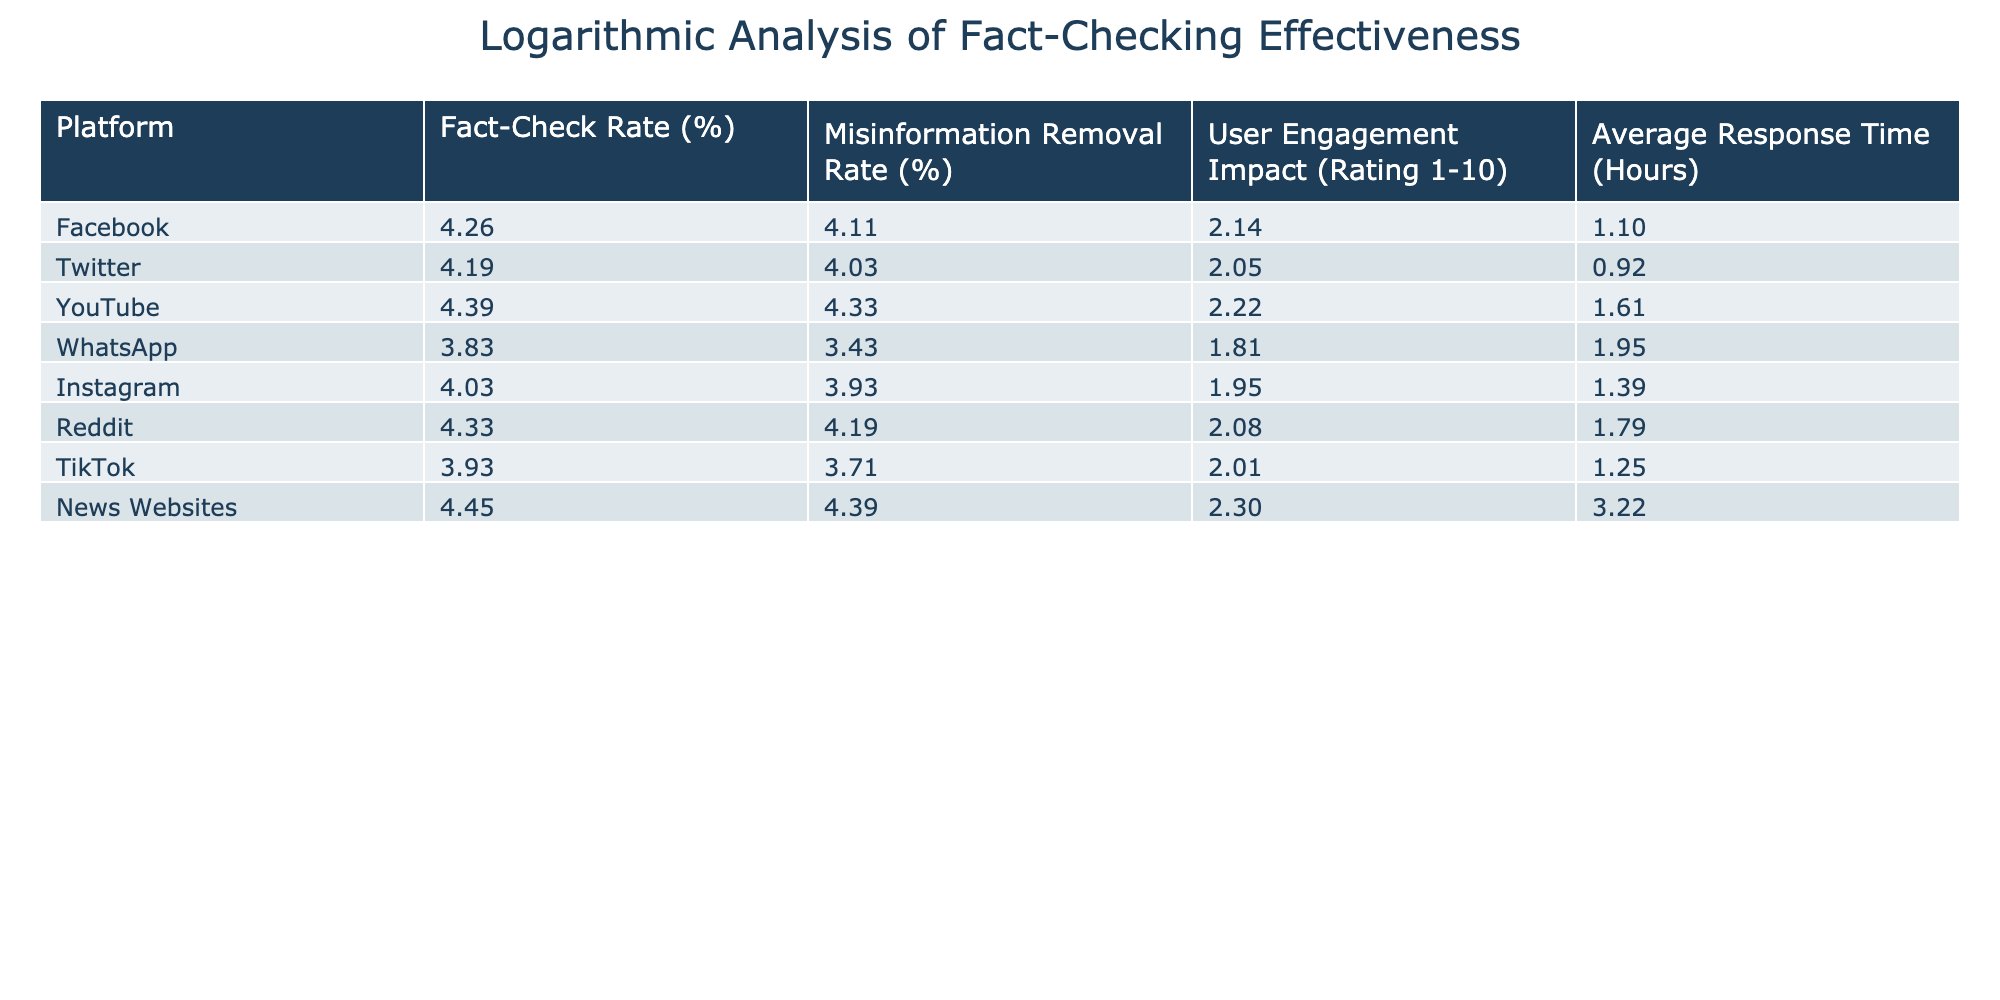What is the Fact-Check Rate for YouTube? The table shows that the Fact-Check Rate for YouTube is listed as 80%. This information can be directly retrieved from the corresponding row for YouTube in the table.
Answer: 80% Which platform has the highest Misinformation Removal Rate? By examining the Misinformation Removal Rate column, News Websites have the highest rate at 80%, which can be confirmed by comparing the respective values of all platforms.
Answer: 80% Is the User Engagement Impact rating for TikTok higher than that of WhatsApp? The User Engagement Impact for TikTok is 6.5 while for WhatsApp it is 5.1. Since 6.5 is greater than 5.1, the statement is true.
Answer: Yes What is the average Fact-Check Rate across all platforms? To find the average Fact-Check Rate, we first sum up all the Fact-Check Rates: 70 + 65 + 80 + 45 + 55 + 75 + 50 + 85 = 625. Then, we divide this sum by the number of platforms, which is 8, giving us an average of 625 / 8 = 78.125.
Answer: 78.125 Which platform has the lowest Average Response Time? By checking the Average Response Time column, I see that the platform with the lowest response time is Twitter, which has an average response time of 1.5 hours, identified by comparing all values in that column.
Answer: 1.5 If you consider Misinformation Removal Rate and User Engagement Impact, which platform exhibits the highest combined effectiveness? To determine combined effectiveness, I add Misinformation Removal Rate and User Engagement Impact for each platform. The calculations are as follows: Facebook (60 + 7.5 = 67.5), Twitter (55 + 6.8 = 61.8), YouTube (75 + 8.2 = 83.2), WhatsApp (30 + 5.1 = 35.1), Instagram (50 + 6.0 = 56), Reddit (65 + 7.0 = 72), TikTok (40 + 6.5 = 46.5), and News Websites (80 + 9.0 = 89). News Websites have the highest combined effectiveness at 89.
Answer: News Websites True or False: The average response time for Instagram is more than 3 hours. The table states that Instagram has an average response time of 3 hours. Since the statement mentions "more," it is false.
Answer: False 